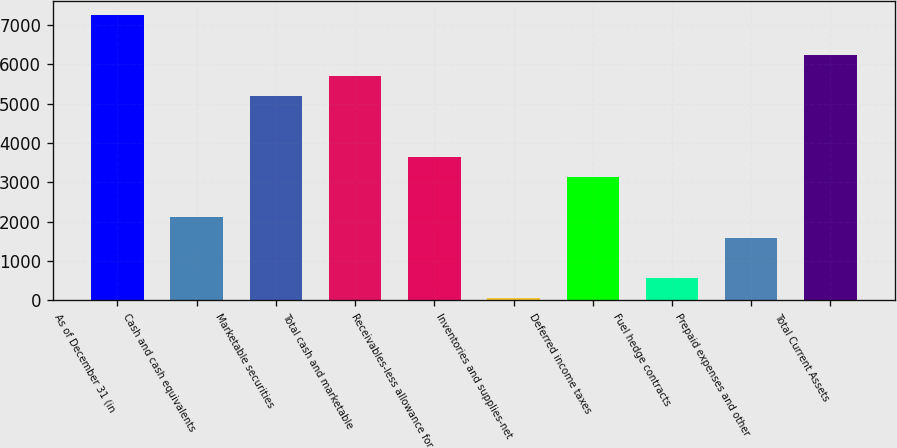Convert chart to OTSL. <chart><loc_0><loc_0><loc_500><loc_500><bar_chart><fcel>As of December 31 (in<fcel>Cash and cash equivalents<fcel>Marketable securities<fcel>Total cash and marketable<fcel>Receivables-less allowance for<fcel>Inventories and supplies-net<fcel>Deferred income taxes<fcel>Fuel hedge contracts<fcel>Prepaid expenses and other<fcel>Total Current Assets<nl><fcel>7255.28<fcel>2104.58<fcel>5195<fcel>5710.07<fcel>3649.79<fcel>44.3<fcel>3134.72<fcel>559.37<fcel>1589.51<fcel>6225.14<nl></chart> 